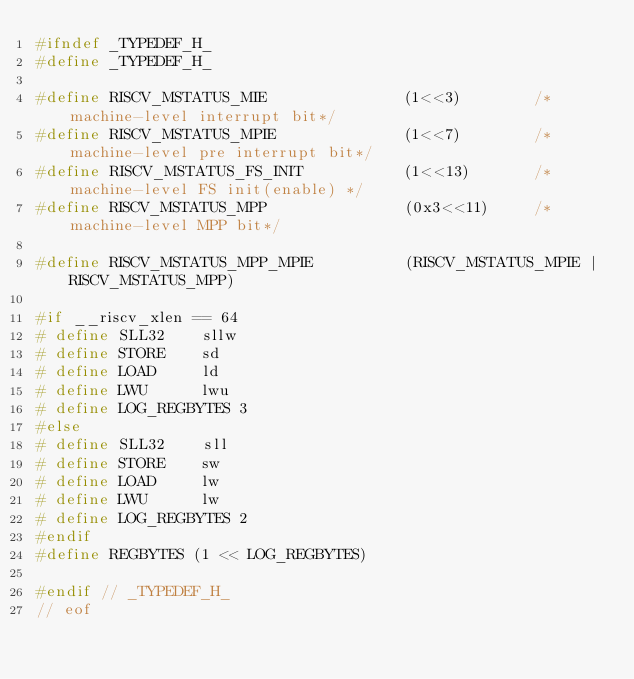Convert code to text. <code><loc_0><loc_0><loc_500><loc_500><_C_>#ifndef _TYPEDEF_H_
#define _TYPEDEF_H_

#define RISCV_MSTATUS_MIE               (1<<3)        /*machine-level interrupt bit*/
#define RISCV_MSTATUS_MPIE              (1<<7)        /*machine-level pre interrupt bit*/
#define RISCV_MSTATUS_FS_INIT           (1<<13)       /*machine-level FS init(enable) */
#define RISCV_MSTATUS_MPP               (0x3<<11)     /*machine-level MPP bit*/

#define RISCV_MSTATUS_MPP_MPIE          (RISCV_MSTATUS_MPIE | RISCV_MSTATUS_MPP)

#if __riscv_xlen == 64
# define SLL32    sllw
# define STORE    sd
# define LOAD     ld
# define LWU      lwu
# define LOG_REGBYTES 3
#else
# define SLL32    sll
# define STORE    sw
# define LOAD     lw
# define LWU      lw
# define LOG_REGBYTES 2
#endif
#define REGBYTES (1 << LOG_REGBYTES)

#endif // _TYPEDEF_H_
// eof

</code> 